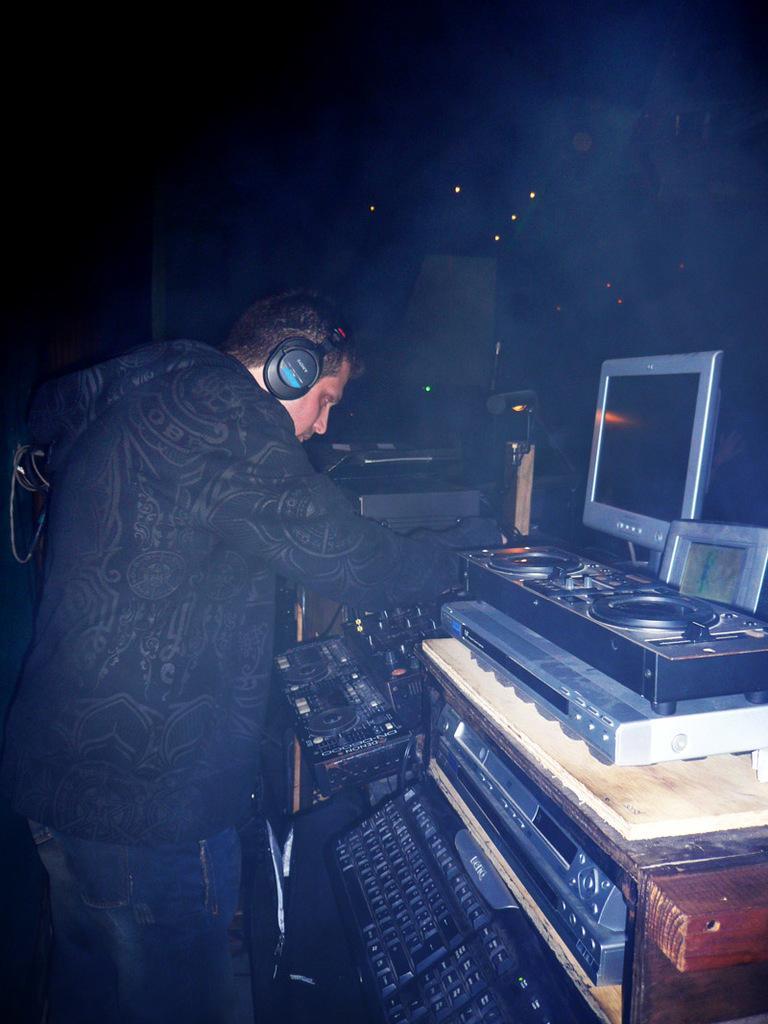Can you describe this image briefly? In this image, we can see a person wearing headset and in the background, there are musical instruments and we can see some lights and a laptop. 